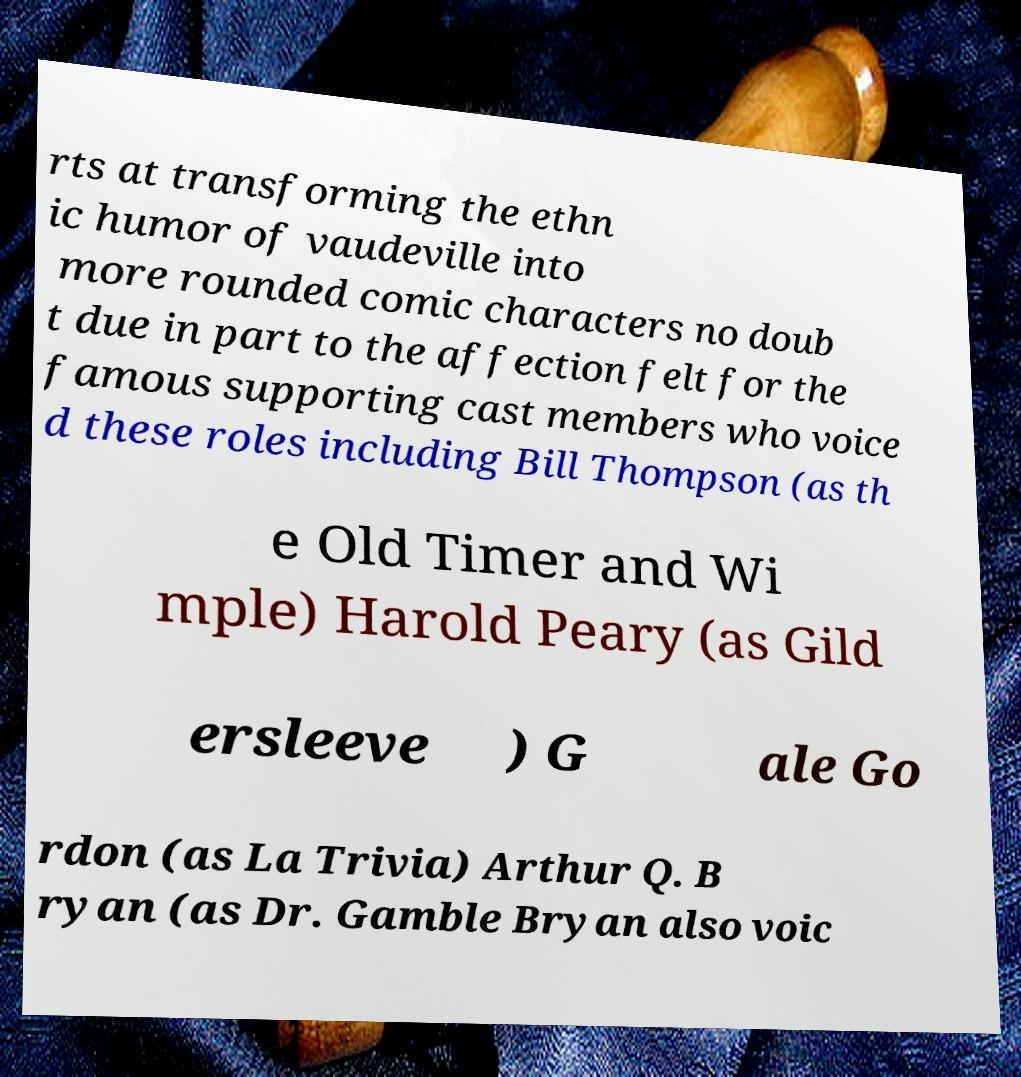Can you accurately transcribe the text from the provided image for me? rts at transforming the ethn ic humor of vaudeville into more rounded comic characters no doub t due in part to the affection felt for the famous supporting cast members who voice d these roles including Bill Thompson (as th e Old Timer and Wi mple) Harold Peary (as Gild ersleeve ) G ale Go rdon (as La Trivia) Arthur Q. B ryan (as Dr. Gamble Bryan also voic 